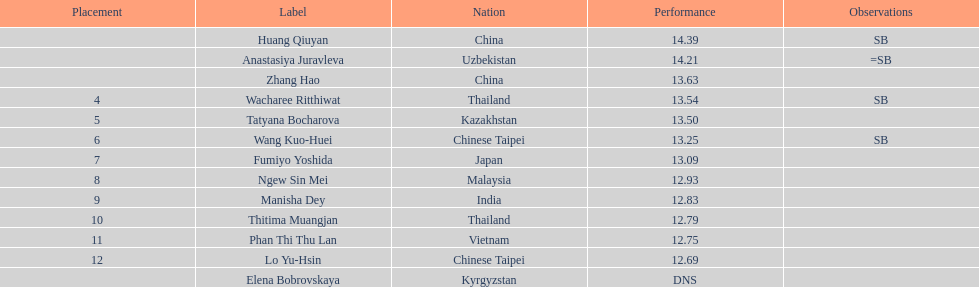How many competitors had less than 13.00 points? 6. 